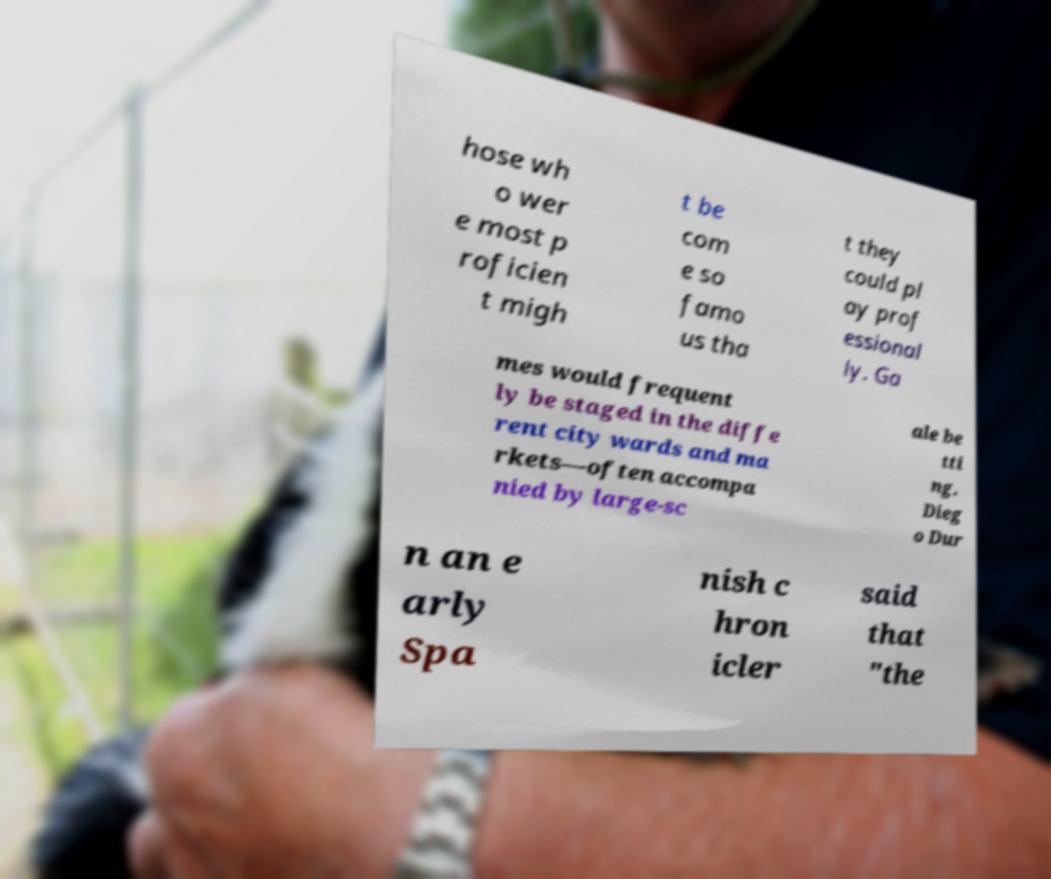Please identify and transcribe the text found in this image. hose wh o wer e most p roficien t migh t be com e so famo us tha t they could pl ay prof essional ly. Ga mes would frequent ly be staged in the diffe rent city wards and ma rkets—often accompa nied by large-sc ale be tti ng. Dieg o Dur n an e arly Spa nish c hron icler said that "the 